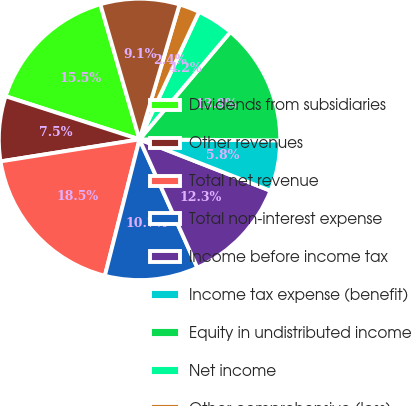Convert chart to OTSL. <chart><loc_0><loc_0><loc_500><loc_500><pie_chart><fcel>Dividends from subsidiaries<fcel>Other revenues<fcel>Total net revenue<fcel>Total non-interest expense<fcel>Income before income tax<fcel>Income tax expense (benefit)<fcel>Equity in undistributed income<fcel>Net income<fcel>Other comprehensive (loss)<fcel>Comprehensive income<nl><fcel>15.55%<fcel>7.46%<fcel>18.54%<fcel>10.7%<fcel>12.31%<fcel>5.84%<fcel>13.93%<fcel>4.23%<fcel>2.36%<fcel>9.08%<nl></chart> 